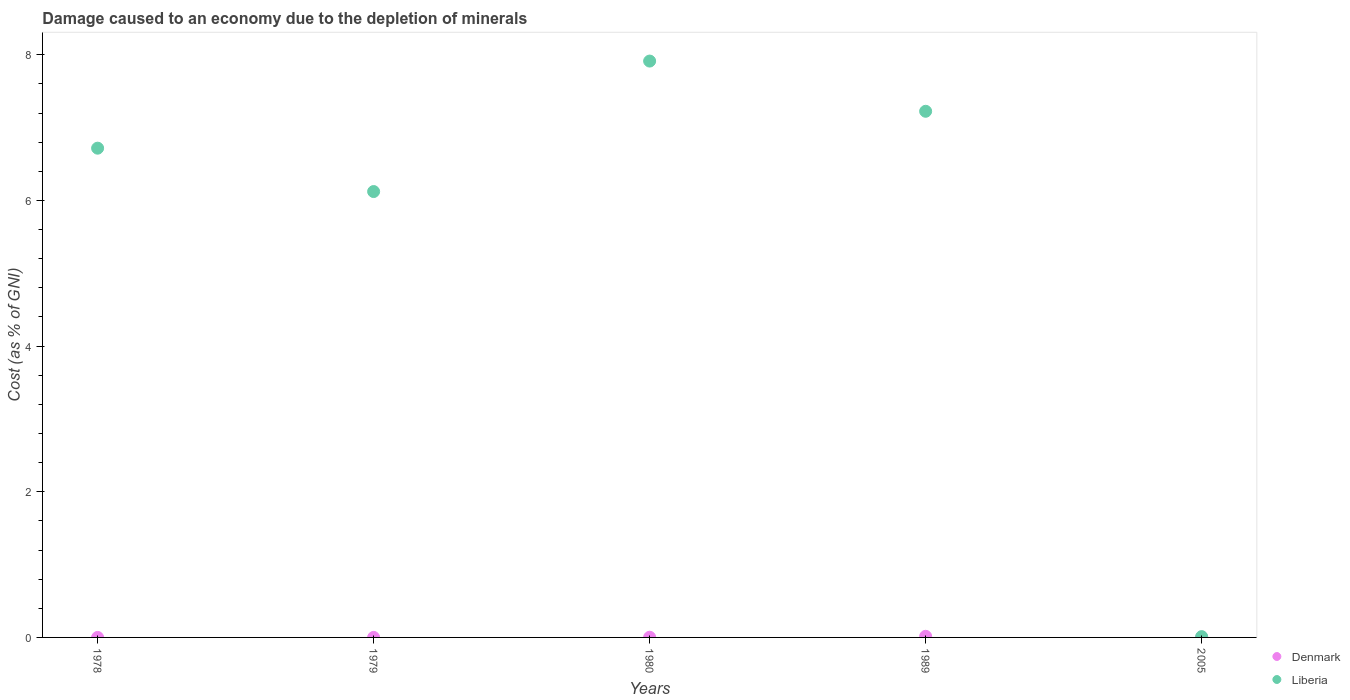What is the cost of damage caused due to the depletion of minerals in Liberia in 2005?
Keep it short and to the point. 0.01. Across all years, what is the maximum cost of damage caused due to the depletion of minerals in Liberia?
Offer a terse response. 7.91. Across all years, what is the minimum cost of damage caused due to the depletion of minerals in Liberia?
Your response must be concise. 0.01. In which year was the cost of damage caused due to the depletion of minerals in Denmark minimum?
Give a very brief answer. 1978. What is the total cost of damage caused due to the depletion of minerals in Liberia in the graph?
Give a very brief answer. 27.99. What is the difference between the cost of damage caused due to the depletion of minerals in Denmark in 1979 and that in 1989?
Provide a succinct answer. -0.02. What is the difference between the cost of damage caused due to the depletion of minerals in Denmark in 1989 and the cost of damage caused due to the depletion of minerals in Liberia in 1978?
Your answer should be very brief. -6.7. What is the average cost of damage caused due to the depletion of minerals in Liberia per year?
Ensure brevity in your answer.  5.6. In the year 2005, what is the difference between the cost of damage caused due to the depletion of minerals in Liberia and cost of damage caused due to the depletion of minerals in Denmark?
Your answer should be compact. 0.01. What is the ratio of the cost of damage caused due to the depletion of minerals in Liberia in 1980 to that in 2005?
Offer a terse response. 726.73. Is the difference between the cost of damage caused due to the depletion of minerals in Liberia in 1979 and 1989 greater than the difference between the cost of damage caused due to the depletion of minerals in Denmark in 1979 and 1989?
Your answer should be very brief. No. What is the difference between the highest and the second highest cost of damage caused due to the depletion of minerals in Liberia?
Keep it short and to the point. 0.69. What is the difference between the highest and the lowest cost of damage caused due to the depletion of minerals in Denmark?
Offer a terse response. 0.02. Is the sum of the cost of damage caused due to the depletion of minerals in Denmark in 1980 and 2005 greater than the maximum cost of damage caused due to the depletion of minerals in Liberia across all years?
Your answer should be very brief. No. Does the cost of damage caused due to the depletion of minerals in Denmark monotonically increase over the years?
Make the answer very short. No. Is the cost of damage caused due to the depletion of minerals in Denmark strictly greater than the cost of damage caused due to the depletion of minerals in Liberia over the years?
Give a very brief answer. No. How many dotlines are there?
Your answer should be compact. 2. Are the values on the major ticks of Y-axis written in scientific E-notation?
Your answer should be very brief. No. How many legend labels are there?
Your answer should be compact. 2. How are the legend labels stacked?
Your response must be concise. Vertical. What is the title of the graph?
Give a very brief answer. Damage caused to an economy due to the depletion of minerals. Does "Comoros" appear as one of the legend labels in the graph?
Your response must be concise. No. What is the label or title of the Y-axis?
Your answer should be very brief. Cost (as % of GNI). What is the Cost (as % of GNI) of Denmark in 1978?
Provide a succinct answer. 0. What is the Cost (as % of GNI) in Liberia in 1978?
Your response must be concise. 6.72. What is the Cost (as % of GNI) in Denmark in 1979?
Ensure brevity in your answer.  0. What is the Cost (as % of GNI) of Liberia in 1979?
Your answer should be very brief. 6.12. What is the Cost (as % of GNI) of Denmark in 1980?
Make the answer very short. 0. What is the Cost (as % of GNI) of Liberia in 1980?
Offer a terse response. 7.91. What is the Cost (as % of GNI) of Denmark in 1989?
Provide a succinct answer. 0.02. What is the Cost (as % of GNI) of Liberia in 1989?
Your answer should be compact. 7.22. What is the Cost (as % of GNI) in Denmark in 2005?
Your answer should be compact. 0. What is the Cost (as % of GNI) in Liberia in 2005?
Keep it short and to the point. 0.01. Across all years, what is the maximum Cost (as % of GNI) in Denmark?
Your answer should be compact. 0.02. Across all years, what is the maximum Cost (as % of GNI) in Liberia?
Offer a very short reply. 7.91. Across all years, what is the minimum Cost (as % of GNI) in Denmark?
Make the answer very short. 0. Across all years, what is the minimum Cost (as % of GNI) of Liberia?
Provide a short and direct response. 0.01. What is the total Cost (as % of GNI) of Denmark in the graph?
Your response must be concise. 0.02. What is the total Cost (as % of GNI) of Liberia in the graph?
Your answer should be compact. 27.99. What is the difference between the Cost (as % of GNI) of Denmark in 1978 and that in 1979?
Provide a short and direct response. -0. What is the difference between the Cost (as % of GNI) in Liberia in 1978 and that in 1979?
Offer a terse response. 0.6. What is the difference between the Cost (as % of GNI) in Denmark in 1978 and that in 1980?
Keep it short and to the point. -0. What is the difference between the Cost (as % of GNI) in Liberia in 1978 and that in 1980?
Provide a short and direct response. -1.2. What is the difference between the Cost (as % of GNI) of Denmark in 1978 and that in 1989?
Keep it short and to the point. -0.02. What is the difference between the Cost (as % of GNI) of Liberia in 1978 and that in 1989?
Provide a short and direct response. -0.51. What is the difference between the Cost (as % of GNI) in Denmark in 1978 and that in 2005?
Keep it short and to the point. -0. What is the difference between the Cost (as % of GNI) of Liberia in 1978 and that in 2005?
Your answer should be very brief. 6.71. What is the difference between the Cost (as % of GNI) in Denmark in 1979 and that in 1980?
Your answer should be compact. -0. What is the difference between the Cost (as % of GNI) of Liberia in 1979 and that in 1980?
Your answer should be very brief. -1.79. What is the difference between the Cost (as % of GNI) of Denmark in 1979 and that in 1989?
Offer a terse response. -0.02. What is the difference between the Cost (as % of GNI) of Liberia in 1979 and that in 1989?
Your answer should be very brief. -1.1. What is the difference between the Cost (as % of GNI) in Denmark in 1979 and that in 2005?
Ensure brevity in your answer.  -0. What is the difference between the Cost (as % of GNI) in Liberia in 1979 and that in 2005?
Offer a terse response. 6.11. What is the difference between the Cost (as % of GNI) of Denmark in 1980 and that in 1989?
Your response must be concise. -0.01. What is the difference between the Cost (as % of GNI) of Liberia in 1980 and that in 1989?
Make the answer very short. 0.69. What is the difference between the Cost (as % of GNI) in Denmark in 1980 and that in 2005?
Offer a very short reply. 0. What is the difference between the Cost (as % of GNI) of Liberia in 1980 and that in 2005?
Provide a short and direct response. 7.9. What is the difference between the Cost (as % of GNI) in Denmark in 1989 and that in 2005?
Your response must be concise. 0.01. What is the difference between the Cost (as % of GNI) in Liberia in 1989 and that in 2005?
Keep it short and to the point. 7.21. What is the difference between the Cost (as % of GNI) in Denmark in 1978 and the Cost (as % of GNI) in Liberia in 1979?
Ensure brevity in your answer.  -6.12. What is the difference between the Cost (as % of GNI) in Denmark in 1978 and the Cost (as % of GNI) in Liberia in 1980?
Provide a short and direct response. -7.91. What is the difference between the Cost (as % of GNI) of Denmark in 1978 and the Cost (as % of GNI) of Liberia in 1989?
Your answer should be very brief. -7.22. What is the difference between the Cost (as % of GNI) of Denmark in 1978 and the Cost (as % of GNI) of Liberia in 2005?
Provide a succinct answer. -0.01. What is the difference between the Cost (as % of GNI) of Denmark in 1979 and the Cost (as % of GNI) of Liberia in 1980?
Provide a succinct answer. -7.91. What is the difference between the Cost (as % of GNI) in Denmark in 1979 and the Cost (as % of GNI) in Liberia in 1989?
Your answer should be compact. -7.22. What is the difference between the Cost (as % of GNI) in Denmark in 1979 and the Cost (as % of GNI) in Liberia in 2005?
Make the answer very short. -0.01. What is the difference between the Cost (as % of GNI) in Denmark in 1980 and the Cost (as % of GNI) in Liberia in 1989?
Offer a terse response. -7.22. What is the difference between the Cost (as % of GNI) of Denmark in 1980 and the Cost (as % of GNI) of Liberia in 2005?
Offer a terse response. -0.01. What is the difference between the Cost (as % of GNI) in Denmark in 1989 and the Cost (as % of GNI) in Liberia in 2005?
Provide a succinct answer. 0. What is the average Cost (as % of GNI) in Denmark per year?
Your answer should be compact. 0. What is the average Cost (as % of GNI) of Liberia per year?
Keep it short and to the point. 5.6. In the year 1978, what is the difference between the Cost (as % of GNI) in Denmark and Cost (as % of GNI) in Liberia?
Keep it short and to the point. -6.72. In the year 1979, what is the difference between the Cost (as % of GNI) of Denmark and Cost (as % of GNI) of Liberia?
Provide a succinct answer. -6.12. In the year 1980, what is the difference between the Cost (as % of GNI) of Denmark and Cost (as % of GNI) of Liberia?
Offer a terse response. -7.91. In the year 1989, what is the difference between the Cost (as % of GNI) of Denmark and Cost (as % of GNI) of Liberia?
Ensure brevity in your answer.  -7.21. In the year 2005, what is the difference between the Cost (as % of GNI) of Denmark and Cost (as % of GNI) of Liberia?
Keep it short and to the point. -0.01. What is the ratio of the Cost (as % of GNI) in Denmark in 1978 to that in 1979?
Give a very brief answer. 0.5. What is the ratio of the Cost (as % of GNI) in Liberia in 1978 to that in 1979?
Your answer should be compact. 1.1. What is the ratio of the Cost (as % of GNI) of Denmark in 1978 to that in 1980?
Offer a very short reply. 0.05. What is the ratio of the Cost (as % of GNI) in Liberia in 1978 to that in 1980?
Ensure brevity in your answer.  0.85. What is the ratio of the Cost (as % of GNI) in Denmark in 1978 to that in 1989?
Offer a very short reply. 0.01. What is the ratio of the Cost (as % of GNI) in Liberia in 1978 to that in 1989?
Ensure brevity in your answer.  0.93. What is the ratio of the Cost (as % of GNI) of Denmark in 1978 to that in 2005?
Ensure brevity in your answer.  0.07. What is the ratio of the Cost (as % of GNI) in Liberia in 1978 to that in 2005?
Ensure brevity in your answer.  616.89. What is the ratio of the Cost (as % of GNI) of Denmark in 1979 to that in 1980?
Make the answer very short. 0.09. What is the ratio of the Cost (as % of GNI) of Liberia in 1979 to that in 1980?
Your answer should be compact. 0.77. What is the ratio of the Cost (as % of GNI) in Denmark in 1979 to that in 1989?
Provide a succinct answer. 0.02. What is the ratio of the Cost (as % of GNI) in Liberia in 1979 to that in 1989?
Give a very brief answer. 0.85. What is the ratio of the Cost (as % of GNI) of Denmark in 1979 to that in 2005?
Offer a terse response. 0.14. What is the ratio of the Cost (as % of GNI) of Liberia in 1979 to that in 2005?
Provide a short and direct response. 562.2. What is the ratio of the Cost (as % of GNI) in Denmark in 1980 to that in 1989?
Your response must be concise. 0.18. What is the ratio of the Cost (as % of GNI) in Liberia in 1980 to that in 1989?
Your answer should be very brief. 1.1. What is the ratio of the Cost (as % of GNI) in Denmark in 1980 to that in 2005?
Make the answer very short. 1.57. What is the ratio of the Cost (as % of GNI) of Liberia in 1980 to that in 2005?
Your response must be concise. 726.73. What is the ratio of the Cost (as % of GNI) of Denmark in 1989 to that in 2005?
Your answer should be compact. 8.69. What is the ratio of the Cost (as % of GNI) in Liberia in 1989 to that in 2005?
Provide a short and direct response. 663.41. What is the difference between the highest and the second highest Cost (as % of GNI) in Denmark?
Provide a short and direct response. 0.01. What is the difference between the highest and the second highest Cost (as % of GNI) of Liberia?
Your response must be concise. 0.69. What is the difference between the highest and the lowest Cost (as % of GNI) in Denmark?
Ensure brevity in your answer.  0.02. What is the difference between the highest and the lowest Cost (as % of GNI) of Liberia?
Provide a succinct answer. 7.9. 